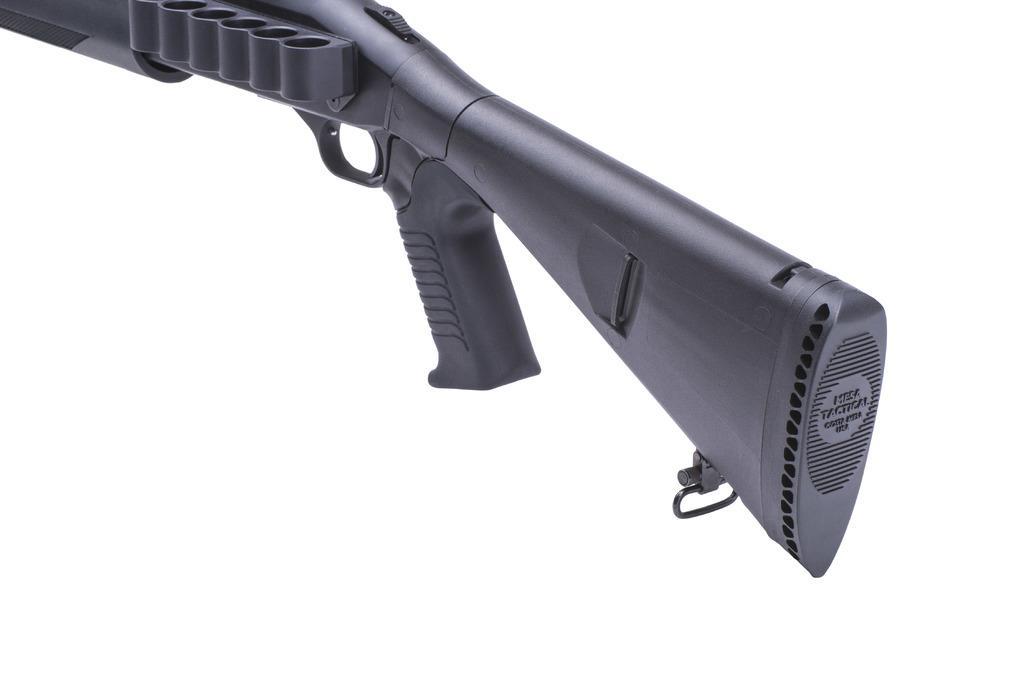Please provide a concise description of this image. In this picture I can see a weapon, it is in black color. 